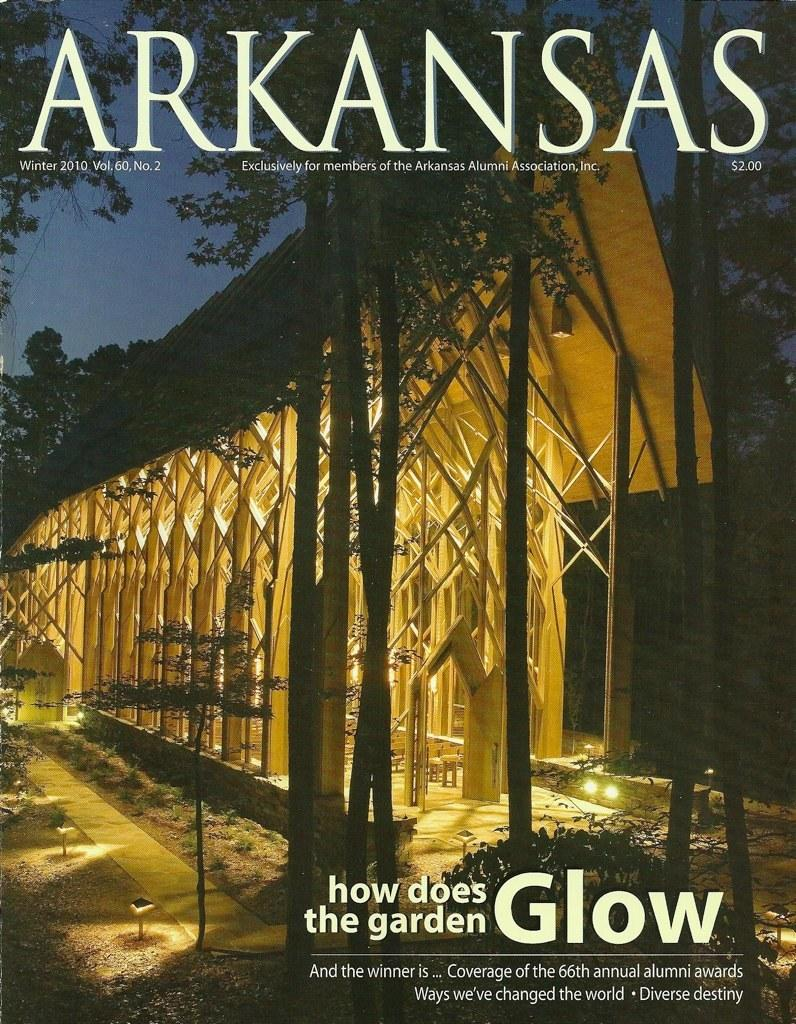What type of publication is the image from? The image is a cover page of a magazine. What is the main feature of the image? There is a garden built on wooden sticks and lights in the image. Is there any text present on the image? Yes, there is text at the top and bottom of the image. Where is the faucet located in the image? There is no faucet present in the image. What is the temperature of the garden in the image? The image does not provide information about the temperature of the garden, only that it is built on wooden sticks and lights. 